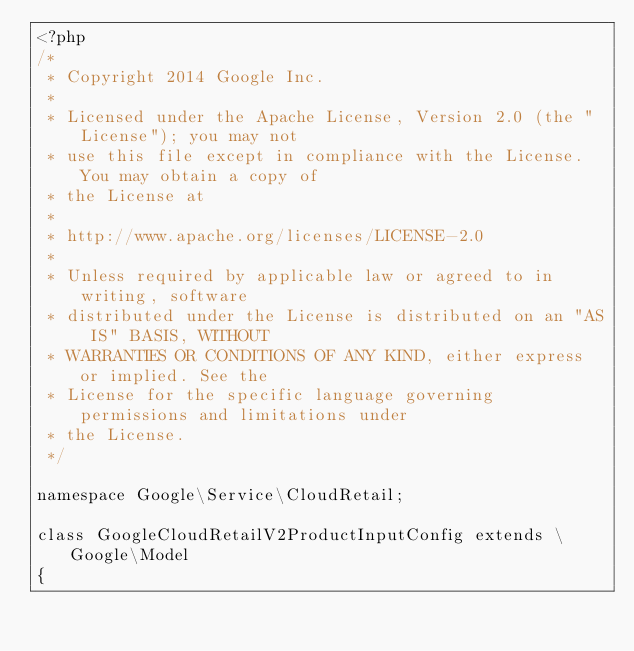Convert code to text. <code><loc_0><loc_0><loc_500><loc_500><_PHP_><?php
/*
 * Copyright 2014 Google Inc.
 *
 * Licensed under the Apache License, Version 2.0 (the "License"); you may not
 * use this file except in compliance with the License. You may obtain a copy of
 * the License at
 *
 * http://www.apache.org/licenses/LICENSE-2.0
 *
 * Unless required by applicable law or agreed to in writing, software
 * distributed under the License is distributed on an "AS IS" BASIS, WITHOUT
 * WARRANTIES OR CONDITIONS OF ANY KIND, either express or implied. See the
 * License for the specific language governing permissions and limitations under
 * the License.
 */

namespace Google\Service\CloudRetail;

class GoogleCloudRetailV2ProductInputConfig extends \Google\Model
{</code> 